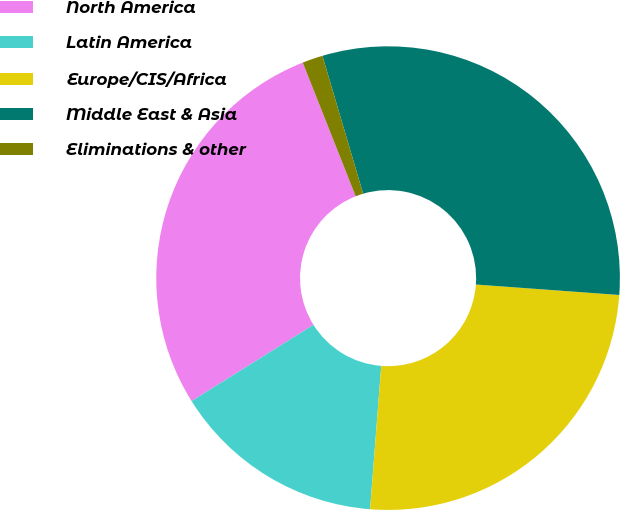Convert chart to OTSL. <chart><loc_0><loc_0><loc_500><loc_500><pie_chart><fcel>North America<fcel>Latin America<fcel>Europe/CIS/Africa<fcel>Middle East & Asia<fcel>Eliminations & other<nl><fcel>27.9%<fcel>14.86%<fcel>25.08%<fcel>30.73%<fcel>1.43%<nl></chart> 